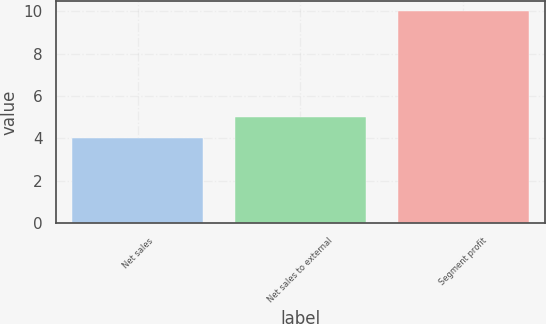Convert chart. <chart><loc_0><loc_0><loc_500><loc_500><bar_chart><fcel>Net sales<fcel>Net sales to external<fcel>Segment profit<nl><fcel>4<fcel>5<fcel>10<nl></chart> 